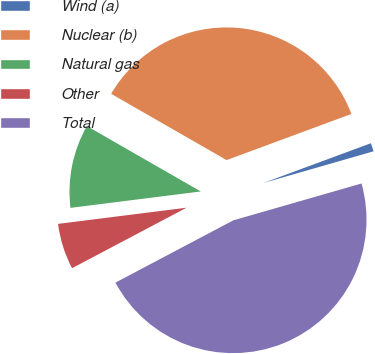<chart> <loc_0><loc_0><loc_500><loc_500><pie_chart><fcel>Wind (a)<fcel>Nuclear (b)<fcel>Natural gas<fcel>Other<fcel>Total<nl><fcel>1.18%<fcel>36.07%<fcel>10.29%<fcel>5.74%<fcel>46.72%<nl></chart> 